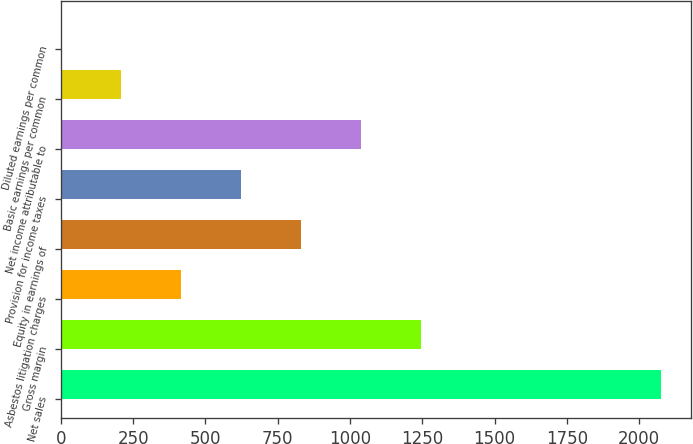Convert chart to OTSL. <chart><loc_0><loc_0><loc_500><loc_500><bar_chart><fcel>Net sales<fcel>Gross margin<fcel>Asbestos litigation charges<fcel>Equity in earnings of<fcel>Provision for income taxes<fcel>Net income attributable to<fcel>Basic earnings per common<fcel>Diluted earnings per common<nl><fcel>2075<fcel>1245.21<fcel>415.41<fcel>830.31<fcel>622.86<fcel>1037.76<fcel>207.96<fcel>0.51<nl></chart> 